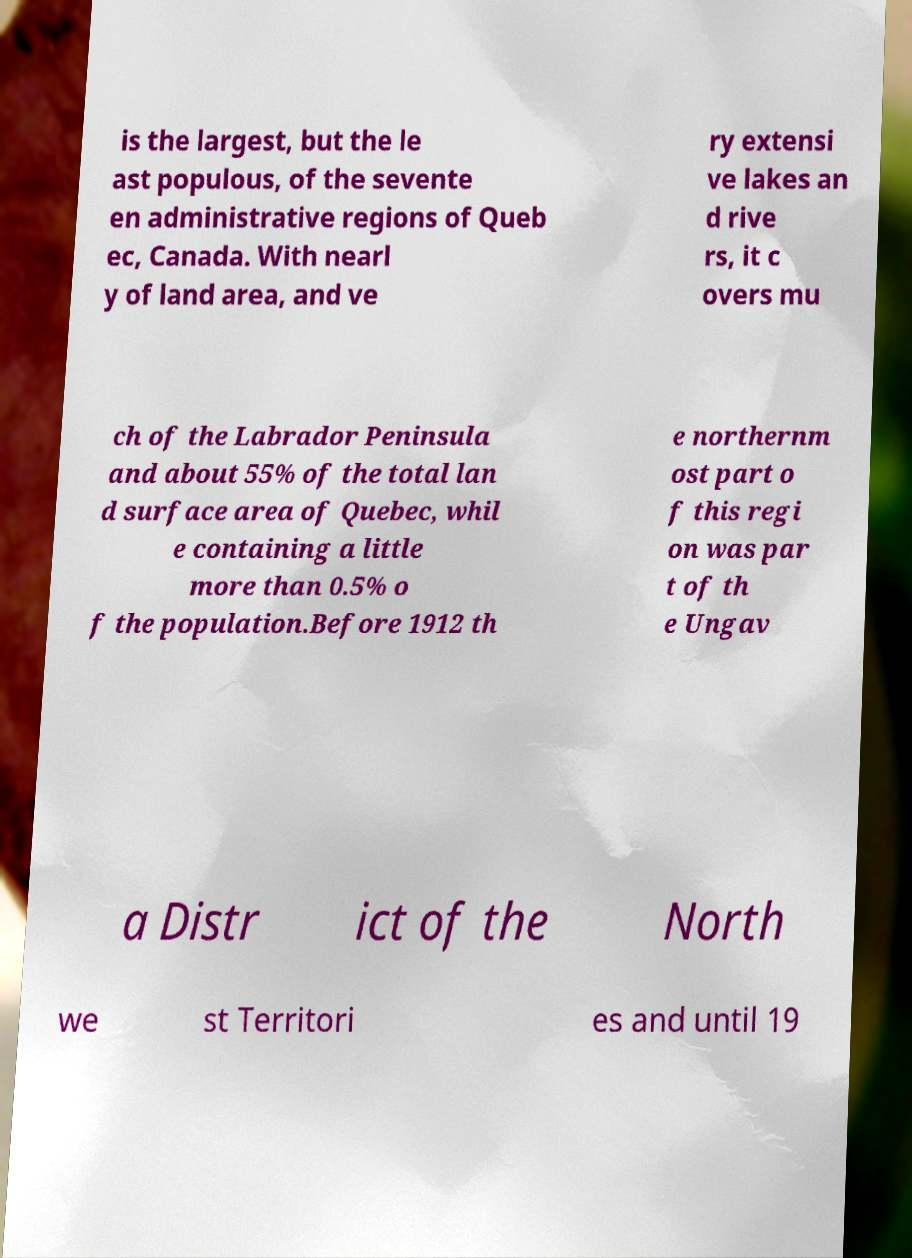There's text embedded in this image that I need extracted. Can you transcribe it verbatim? is the largest, but the le ast populous, of the sevente en administrative regions of Queb ec, Canada. With nearl y of land area, and ve ry extensi ve lakes an d rive rs, it c overs mu ch of the Labrador Peninsula and about 55% of the total lan d surface area of Quebec, whil e containing a little more than 0.5% o f the population.Before 1912 th e northernm ost part o f this regi on was par t of th e Ungav a Distr ict of the North we st Territori es and until 19 